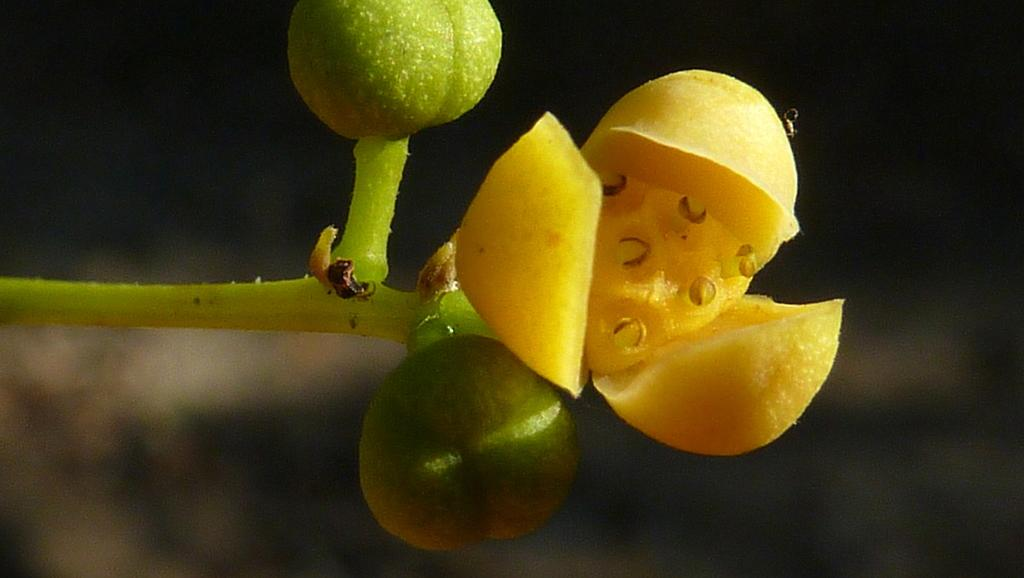What is the main subject in the foreground of the image? There is a flower in the foreground of the image. What can be seen connected to the flower in the image? There is a stem in the foreground of the image. Are there any unopened parts of the flower visible in the image? Yes, there are buds in the foreground of the image. How would you describe the background of the image? The background of the image is blurry. Can you tell me how many icicles are hanging from the flower in the image? There are no icicles present in the image; it features a flower with a stem and buds. Is there any driving activity taking place in the image? There is no driving activity present in the image; it features a flower in the foreground. 